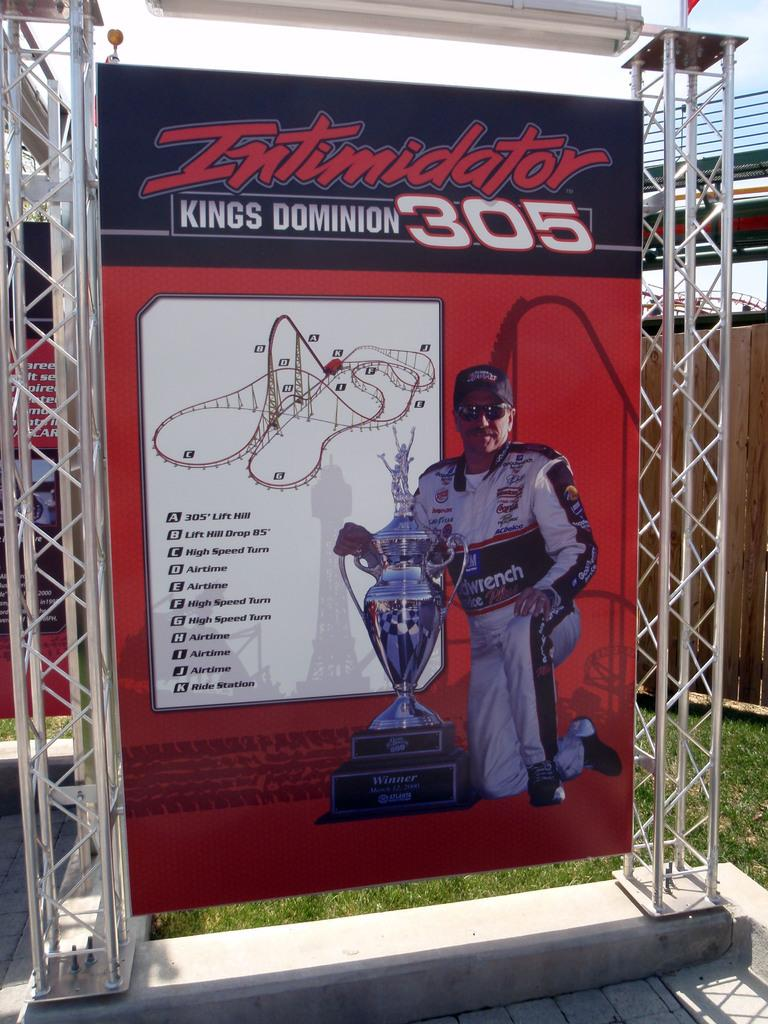Provide a one-sentence caption for the provided image. a man is standing with a trophy in front of an Intimidator 305 sign. 